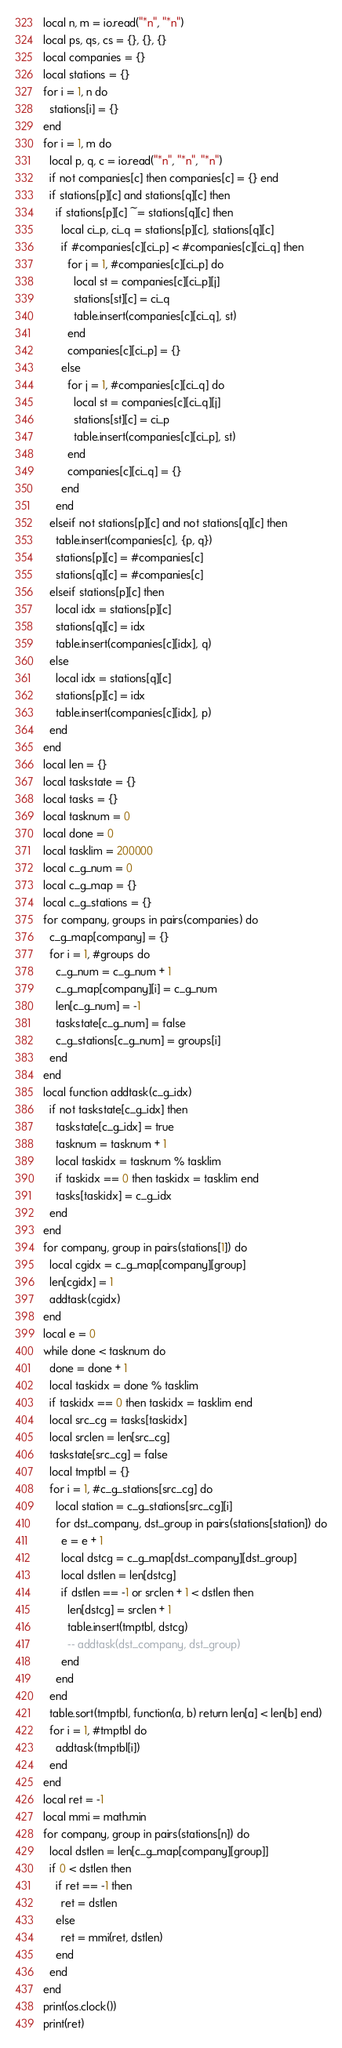Convert code to text. <code><loc_0><loc_0><loc_500><loc_500><_Lua_>local n, m = io.read("*n", "*n")
local ps, qs, cs = {}, {}, {}
local companies = {}
local stations = {}
for i = 1, n do
  stations[i] = {}
end
for i = 1, m do
  local p, q, c = io.read("*n", "*n", "*n")
  if not companies[c] then companies[c] = {} end
  if stations[p][c] and stations[q][c] then
    if stations[p][c] ~= stations[q][c] then
      local ci_p, ci_q = stations[p][c], stations[q][c]
      if #companies[c][ci_p] < #companies[c][ci_q] then
        for j = 1, #companies[c][ci_p] do
          local st = companies[c][ci_p][j]
          stations[st][c] = ci_q
          table.insert(companies[c][ci_q], st)
        end
        companies[c][ci_p] = {}
      else
        for j = 1, #companies[c][ci_q] do
          local st = companies[c][ci_q][j]
          stations[st][c] = ci_p
          table.insert(companies[c][ci_p], st)
        end
        companies[c][ci_q] = {}
      end
    end
  elseif not stations[p][c] and not stations[q][c] then
    table.insert(companies[c], {p, q})
    stations[p][c] = #companies[c]
    stations[q][c] = #companies[c]
  elseif stations[p][c] then
    local idx = stations[p][c]
    stations[q][c] = idx
    table.insert(companies[c][idx], q)
  else
    local idx = stations[q][c]
    stations[p][c] = idx
    table.insert(companies[c][idx], p)
  end
end
local len = {}
local taskstate = {}
local tasks = {}
local tasknum = 0
local done = 0
local tasklim = 200000
local c_g_num = 0
local c_g_map = {}
local c_g_stations = {}
for company, groups in pairs(companies) do
  c_g_map[company] = {}
  for i = 1, #groups do
    c_g_num = c_g_num + 1
    c_g_map[company][i] = c_g_num
    len[c_g_num] = -1
    taskstate[c_g_num] = false
    c_g_stations[c_g_num] = groups[i]
  end
end
local function addtask(c_g_idx)
  if not taskstate[c_g_idx] then
    taskstate[c_g_idx] = true
    tasknum = tasknum + 1
    local taskidx = tasknum % tasklim
    if taskidx == 0 then taskidx = tasklim end
    tasks[taskidx] = c_g_idx
  end
end
for company, group in pairs(stations[1]) do
  local cgidx = c_g_map[company][group]
  len[cgidx] = 1
  addtask(cgidx)
end
local e = 0
while done < tasknum do
  done = done + 1
  local taskidx = done % tasklim
  if taskidx == 0 then taskidx = tasklim end
  local src_cg = tasks[taskidx]
  local srclen = len[src_cg]
  taskstate[src_cg] = false
  local tmptbl = {}
  for i = 1, #c_g_stations[src_cg] do
    local station = c_g_stations[src_cg][i]
    for dst_company, dst_group in pairs(stations[station]) do
      e = e + 1
      local dstcg = c_g_map[dst_company][dst_group]
      local dstlen = len[dstcg]
      if dstlen == -1 or srclen + 1 < dstlen then
        len[dstcg] = srclen + 1
        table.insert(tmptbl, dstcg)
        -- addtask(dst_company, dst_group)
      end
    end
  end
  table.sort(tmptbl, function(a, b) return len[a] < len[b] end)
  for i = 1, #tmptbl do
    addtask(tmptbl[i])
  end
end
local ret = -1
local mmi = math.min
for company, group in pairs(stations[n]) do
  local dstlen = len[c_g_map[company][group]]
  if 0 < dstlen then
    if ret == -1 then
      ret = dstlen
    else
      ret = mmi(ret, dstlen)
    end
  end
end
print(os.clock())
print(ret)
</code> 